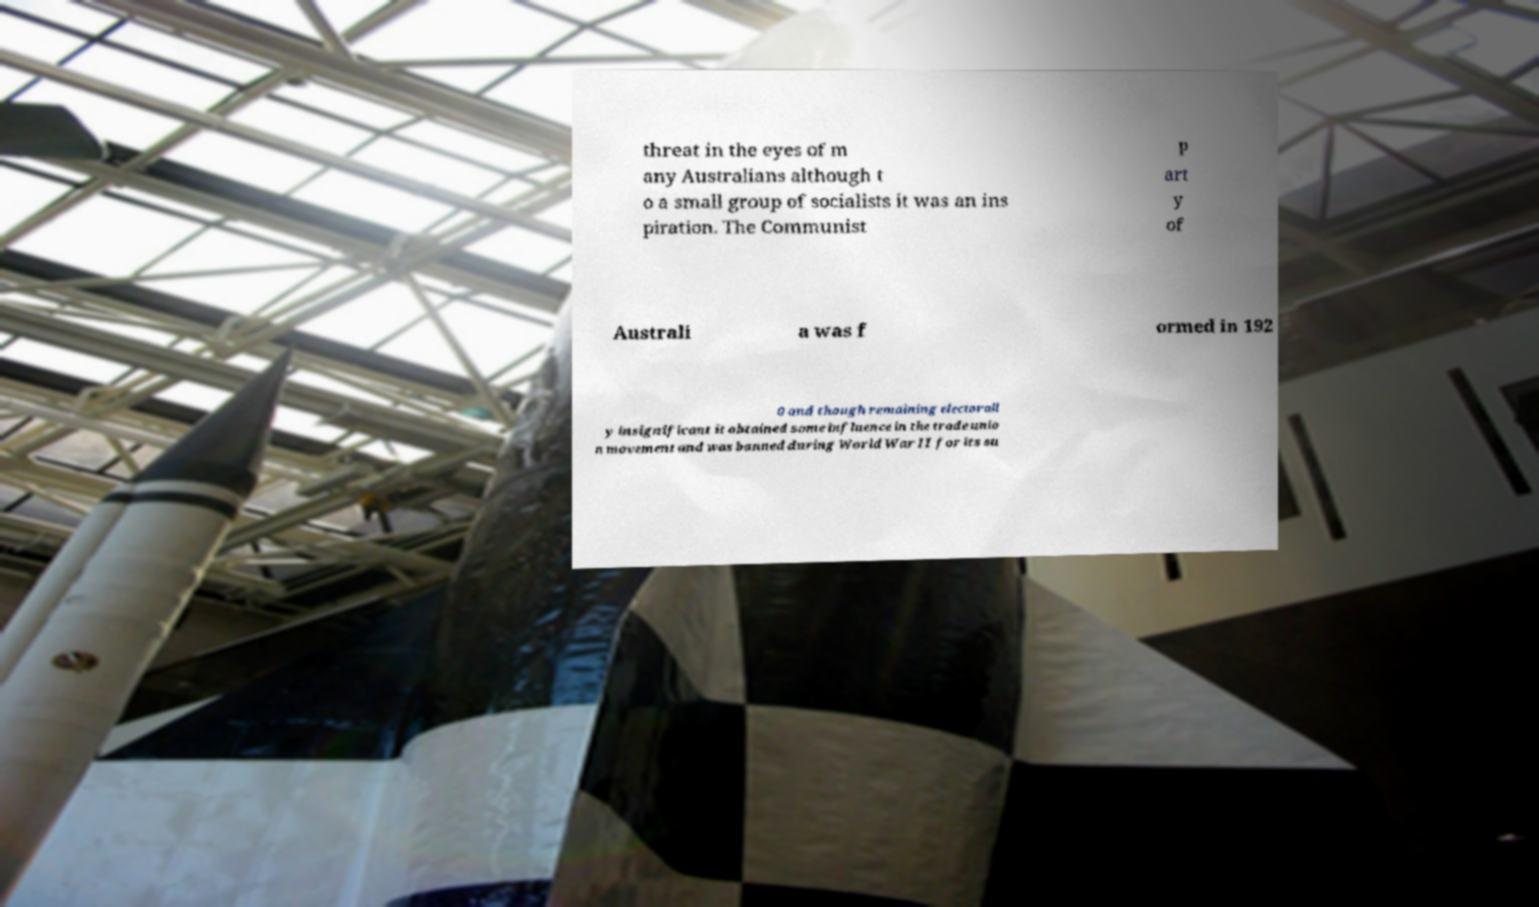Please read and relay the text visible in this image. What does it say? threat in the eyes of m any Australians although t o a small group of socialists it was an ins piration. The Communist P art y of Australi a was f ormed in 192 0 and though remaining electorall y insignificant it obtained some influence in the trade unio n movement and was banned during World War II for its su 